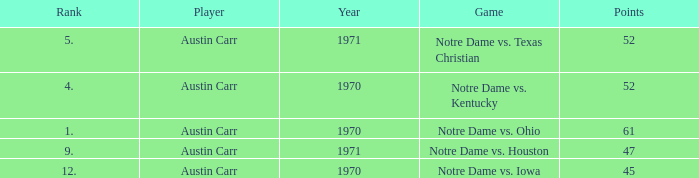Which Rank is the lowest one that has Points larger than 52, and a Year larger than 1970? None. Give me the full table as a dictionary. {'header': ['Rank', 'Player', 'Year', 'Game', 'Points'], 'rows': [['5.', 'Austin Carr', '1971', 'Notre Dame vs. Texas Christian', '52'], ['4.', 'Austin Carr', '1970', 'Notre Dame vs. Kentucky', '52'], ['1.', 'Austin Carr', '1970', 'Notre Dame vs. Ohio', '61'], ['9.', 'Austin Carr', '1971', 'Notre Dame vs. Houston', '47'], ['12.', 'Austin Carr', '1970', 'Notre Dame vs. Iowa', '45']]} 